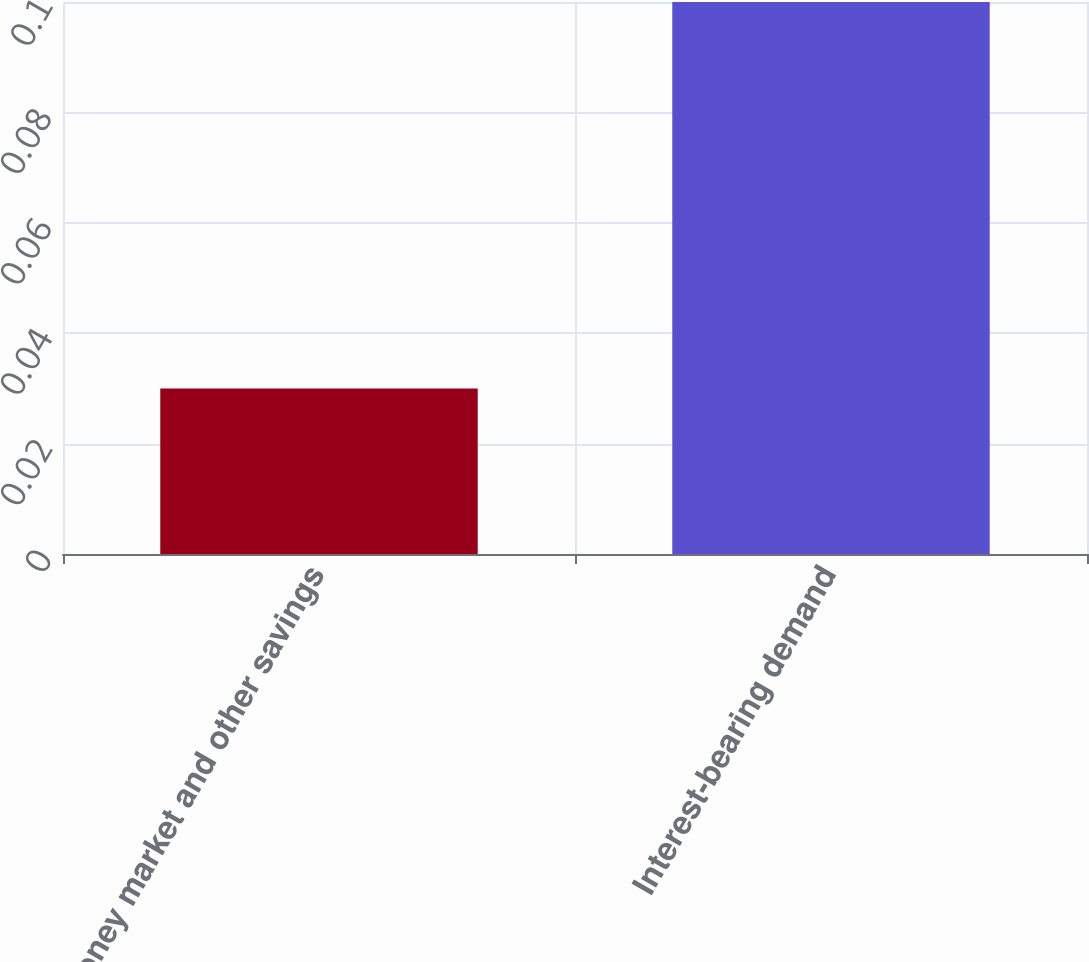Convert chart. <chart><loc_0><loc_0><loc_500><loc_500><bar_chart><fcel>Money market and other savings<fcel>Interest-bearing demand<nl><fcel>0.03<fcel>0.1<nl></chart> 